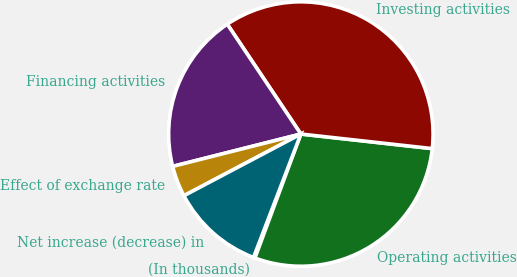Convert chart to OTSL. <chart><loc_0><loc_0><loc_500><loc_500><pie_chart><fcel>(In thousands)<fcel>Operating activities<fcel>Investing activities<fcel>Financing activities<fcel>Effect of exchange rate<fcel>Net increase (decrease) in<nl><fcel>0.19%<fcel>28.88%<fcel>36.15%<fcel>19.54%<fcel>3.79%<fcel>11.44%<nl></chart> 